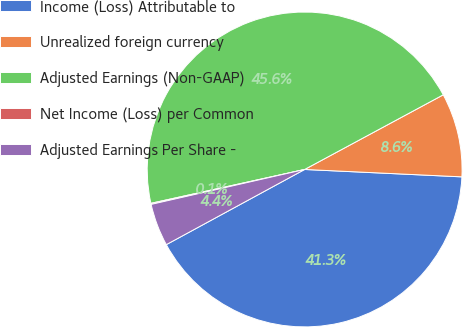Convert chart to OTSL. <chart><loc_0><loc_0><loc_500><loc_500><pie_chart><fcel>Income (Loss) Attributable to<fcel>Unrealized foreign currency<fcel>Adjusted Earnings (Non-GAAP)<fcel>Net Income (Loss) per Common<fcel>Adjusted Earnings Per Share -<nl><fcel>41.33%<fcel>8.61%<fcel>45.59%<fcel>0.11%<fcel>4.36%<nl></chart> 